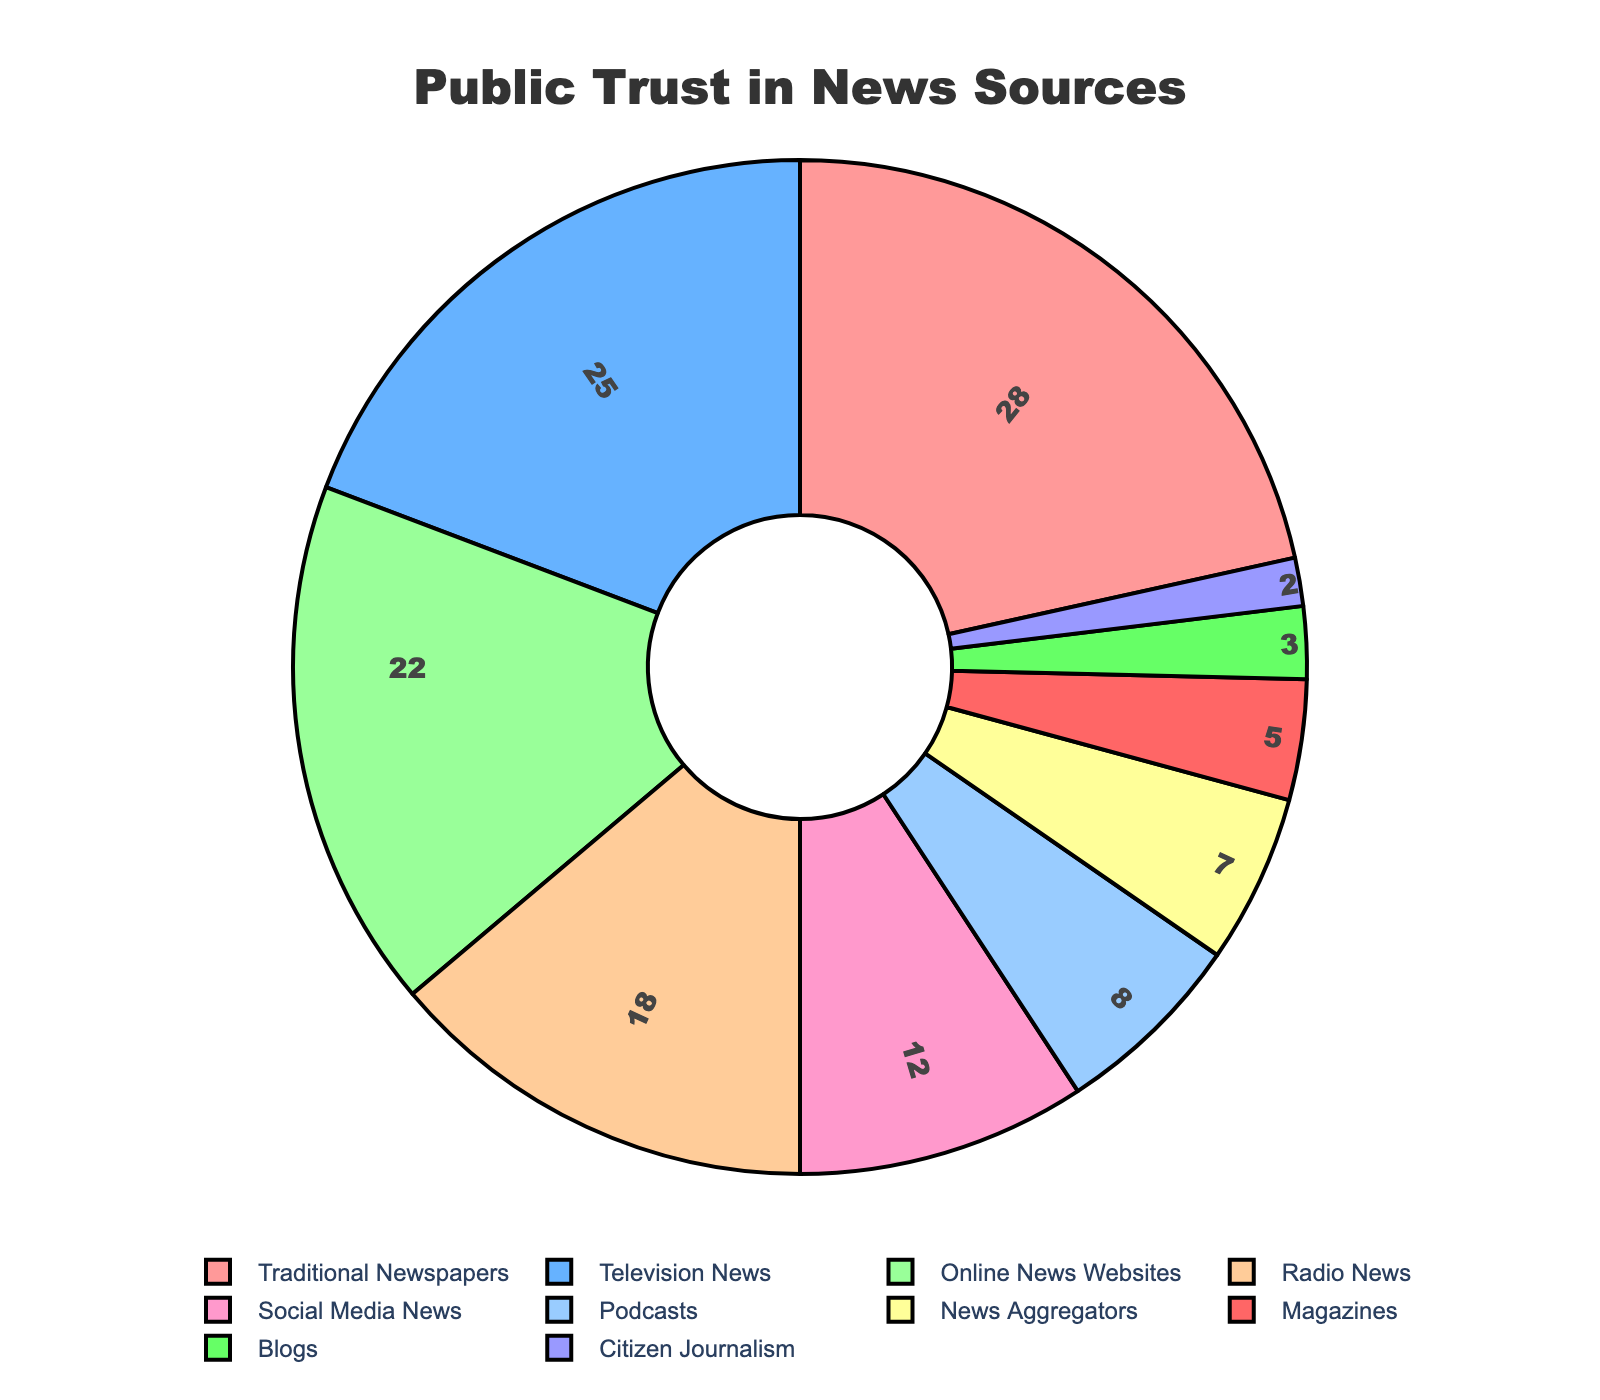What is the most trusted news source according to the pie chart? The pie chart shows the trust levels in different news sources. The segment with the largest value represents the most trusted source. Traditional Newspapers have the highest trust level at 28%.
Answer: Traditional Newspapers Which news source shows a trust level lower than Social Media News? The pie chart indicates Social Media News has a trust level of 12%. Checking the segments with values lower than this, Blogs and Citizen Journalism have trust levels of 3% and 2%, respectively.
Answer: Blogs, Citizen Journalism What are the total trust levels for all online-based news sources combined (Online News Websites, Social Media News, Podcasts, News Aggregators, Blogs)? The trust levels for these sources are 22% (Online News Websites), 12% (Social Media News), 8% (Podcasts), 7% (News Aggregators), and 3% (Blogs). Summing these values gives: 22 + 12 + 8 + 7 + 3 = 52.
Answer: 52 How does trust in Radio News compare to trust in Television News? According to the pie chart, Radio News holds a trust level of 18% while Television News holds 25%. Hence, Radio News has a lower trust level compared to Television News.
Answer: Lower Is the trust level for Traditional Newspapers more than double the trust level of Blogs? Traditional Newspapers have a trust level of 28% while Blogs have 3%. Doubling the trust level of Blogs is 3 × 2 = 6. Since 28% > 6%, the trust level for Traditional Newspapers is more than double that of Blogs.
Answer: Yes Which news sources have a trust level greater than 20%? By examining the trust levels in the pie chart, only Traditional Newspapers (28%), Television News (25%), and Online News Websites (22%) have trust levels greater than 20%.
Answer: Traditional Newspapers, Television News, Online News Websites What is the percentage difference in trust level between the least trusted source and the most trusted source? The least trusted source is Citizen Journalism at 2%, and the most trusted is Traditional Newspapers at 28%. The percentage difference is calculated as 28% - 2% = 26%.
Answer: 26% What color represents Television News in the pie chart? Observing the pie chart, Television News is represented by the second segment from the top, which is colored blue.
Answer: Blue What is the combined trust level of the top two most trusted news sources? The top two sources by trust level are Traditional Newspapers with 28% and Television News with 25%. Their combined trust level is 28 + 25 = 53.
Answer: 53 Does the trust level of News Aggregators surpass half the trust level of Traditional Newspapers? Traditional Newspapers have a trust level of 28%. Half of this value is 28 / 2 = 14. News Aggregators, with a trust level of 7%, do not surpass this value.
Answer: No 